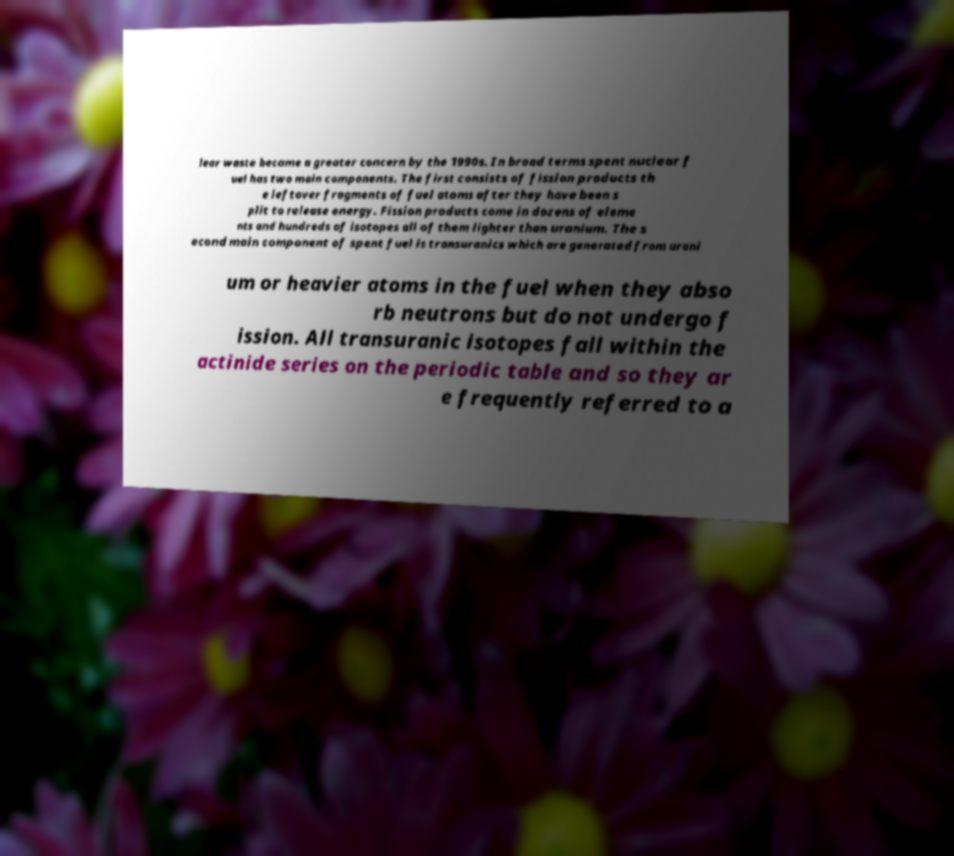There's text embedded in this image that I need extracted. Can you transcribe it verbatim? lear waste became a greater concern by the 1990s. In broad terms spent nuclear f uel has two main components. The first consists of fission products th e leftover fragments of fuel atoms after they have been s plit to release energy. Fission products come in dozens of eleme nts and hundreds of isotopes all of them lighter than uranium. The s econd main component of spent fuel is transuranics which are generated from urani um or heavier atoms in the fuel when they abso rb neutrons but do not undergo f ission. All transuranic isotopes fall within the actinide series on the periodic table and so they ar e frequently referred to a 